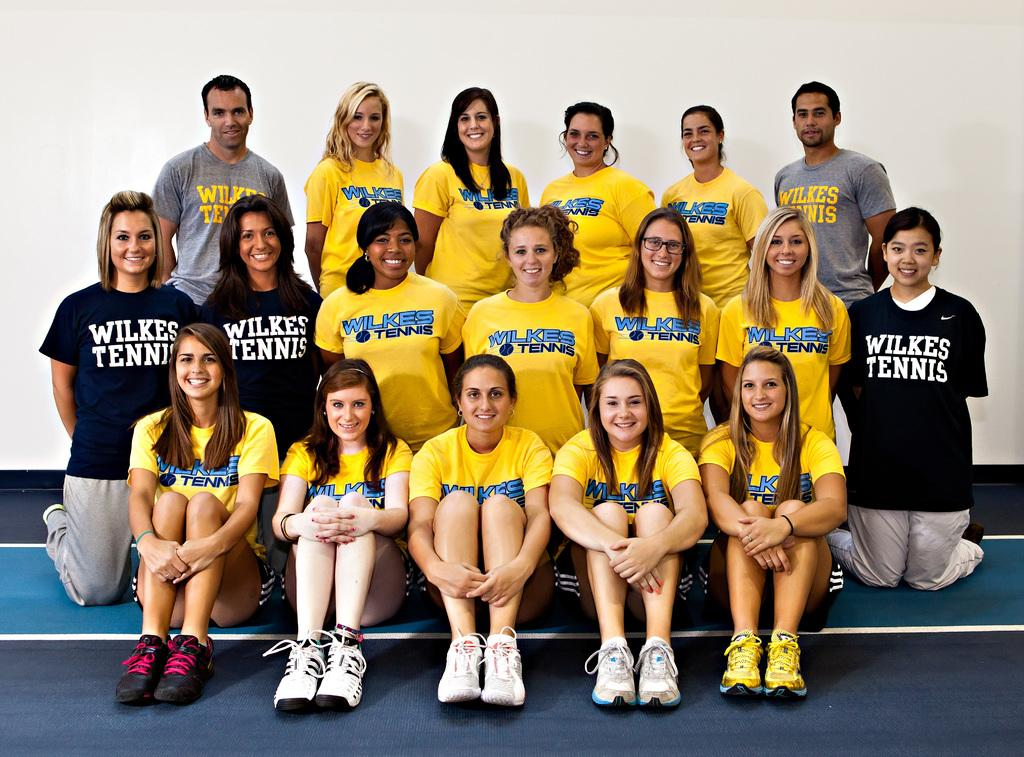<image>
Present a compact description of the photo's key features. a person with a wilkes tennis shirt on 